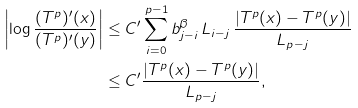Convert formula to latex. <formula><loc_0><loc_0><loc_500><loc_500>\left | \log \frac { ( T ^ { p } ) ^ { \prime } ( x ) } { ( T ^ { p } ) ^ { \prime } ( y ) } \right | & \leq C ^ { \prime } \sum _ { i = 0 } ^ { p - 1 } b _ { j - i } ^ { \beta } \, L _ { i - j } \, \frac { | T ^ { p } ( x ) - T ^ { p } ( y ) | } { L _ { p - j } } \\ & \leq C ^ { \prime } \frac { | T ^ { p } ( x ) - T ^ { p } ( y ) | } { L _ { p - j } } ,</formula> 